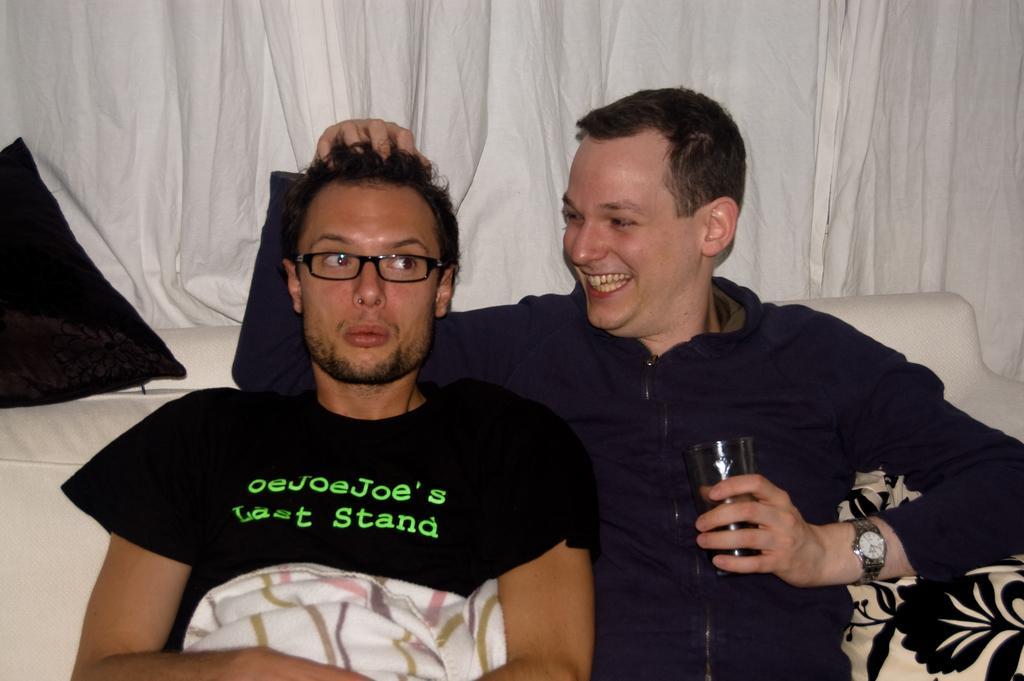Can you describe this image briefly? In this image there are two persons. One person is wearing glasses and the other is smiling and holding the glass and these persons are sitting. In the background we can see white curtains. 